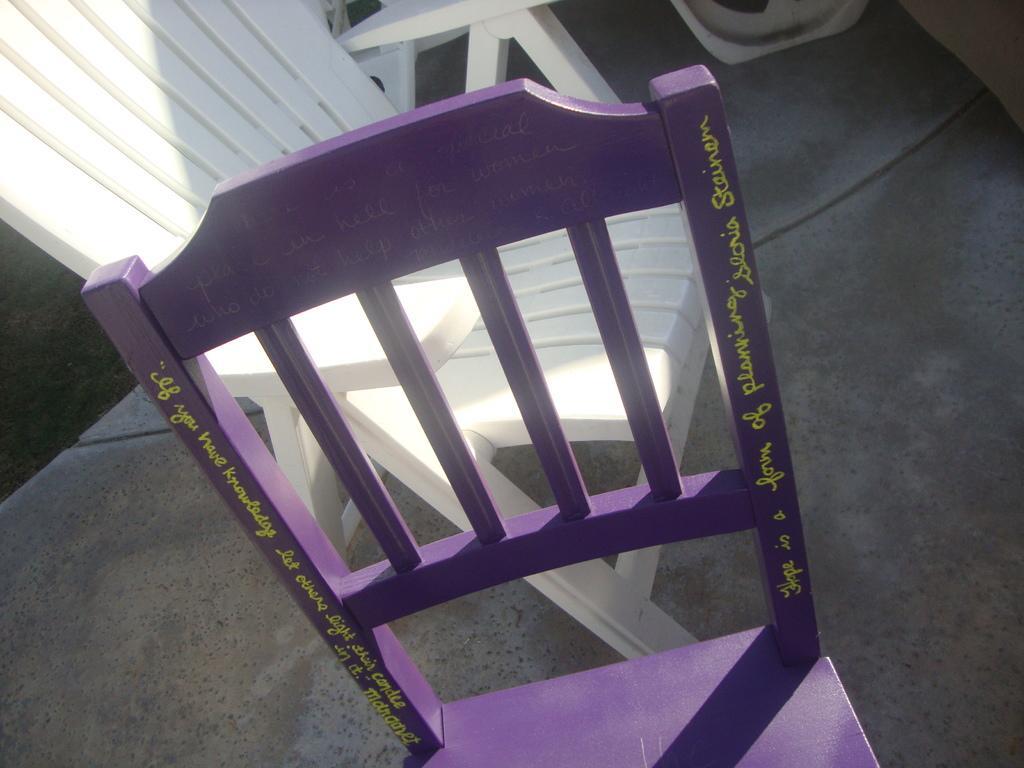How would you summarize this image in a sentence or two? In this picture we can see couple of chairs and we can find some text on the chair. 